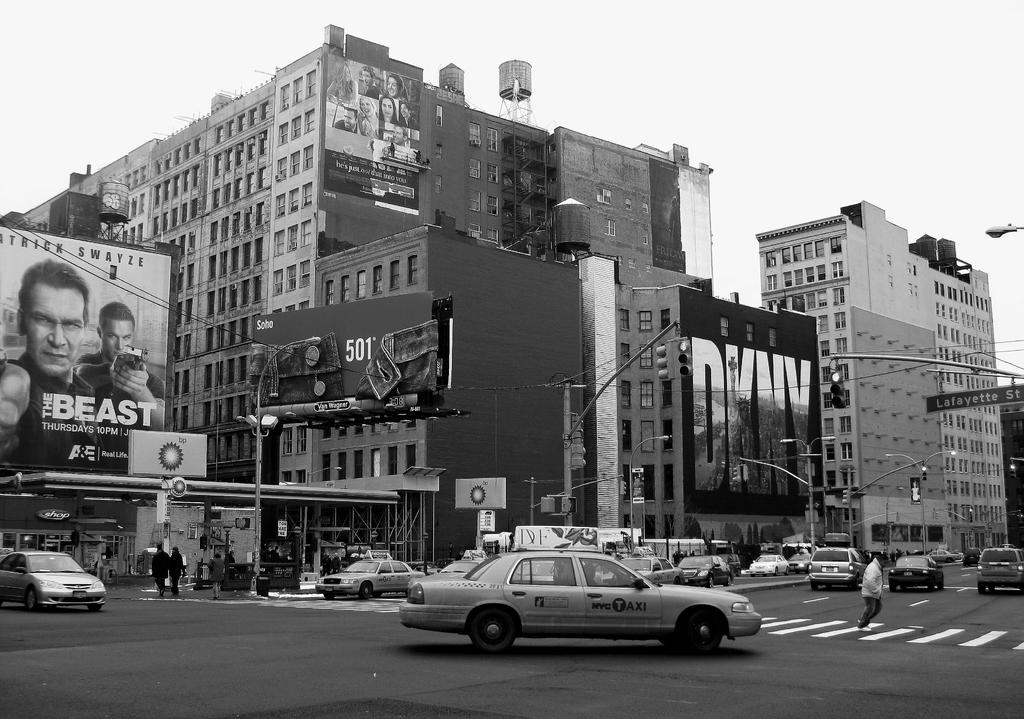<image>
Provide a brief description of the given image. a Beast sign that is above the street 